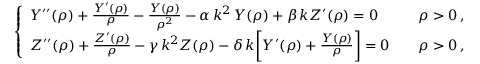Convert formula to latex. <formula><loc_0><loc_0><loc_500><loc_500>\left \{ \begin{array} { l l } { Y ^ { \prime \prime } ( \rho ) + \frac { Y ^ { \prime } ( \rho ) } { \rho } - \frac { Y ( \rho ) } { \rho ^ { 2 } } - \alpha \, k ^ { 2 } \, Y ( \rho ) + \beta \, k Z ^ { \prime } ( \rho ) = 0 \quad } & { \rho > 0 \, , } \\ { Z ^ { \prime \prime } ( \rho ) + \frac { Z ^ { \prime } ( \rho ) } { \rho } - \gamma \, k ^ { 2 } Z ( \rho ) - \delta \, k \left [ Y ^ { \prime } ( \rho ) + \frac { Y ( \rho ) } { \rho } \right ] = 0 \quad } & { \rho > 0 \, , } \end{array}</formula> 